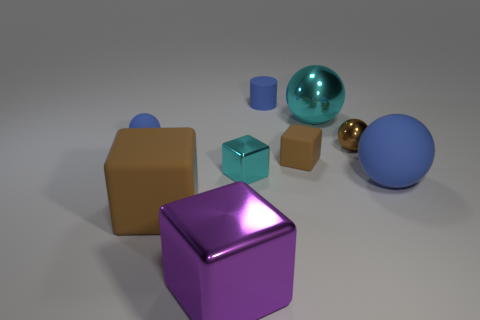What number of cylinders are tiny purple objects or small brown objects?
Your response must be concise. 0. What material is the blue object that is behind the small brown matte thing and right of the tiny blue sphere?
Keep it short and to the point. Rubber. What number of small shiny things are in front of the tiny brown cube?
Offer a very short reply. 1. Is the material of the tiny block to the left of the small blue matte cylinder the same as the tiny blue thing that is on the right side of the cyan cube?
Provide a succinct answer. No. What number of objects are large metallic objects in front of the cyan ball or green rubber things?
Your answer should be very brief. 1. Is the number of purple shiny things that are on the right side of the tiny rubber cube less than the number of big cyan metal things that are behind the small cyan object?
Provide a short and direct response. Yes. What number of other things are the same size as the matte cylinder?
Your answer should be compact. 4. Is the material of the large cyan object the same as the tiny cyan block behind the big rubber sphere?
Give a very brief answer. Yes. What number of things are tiny brown objects that are on the right side of the big cyan metal sphere or blue rubber objects to the left of the big cyan metal thing?
Provide a succinct answer. 3. The tiny metallic block is what color?
Offer a very short reply. Cyan. 